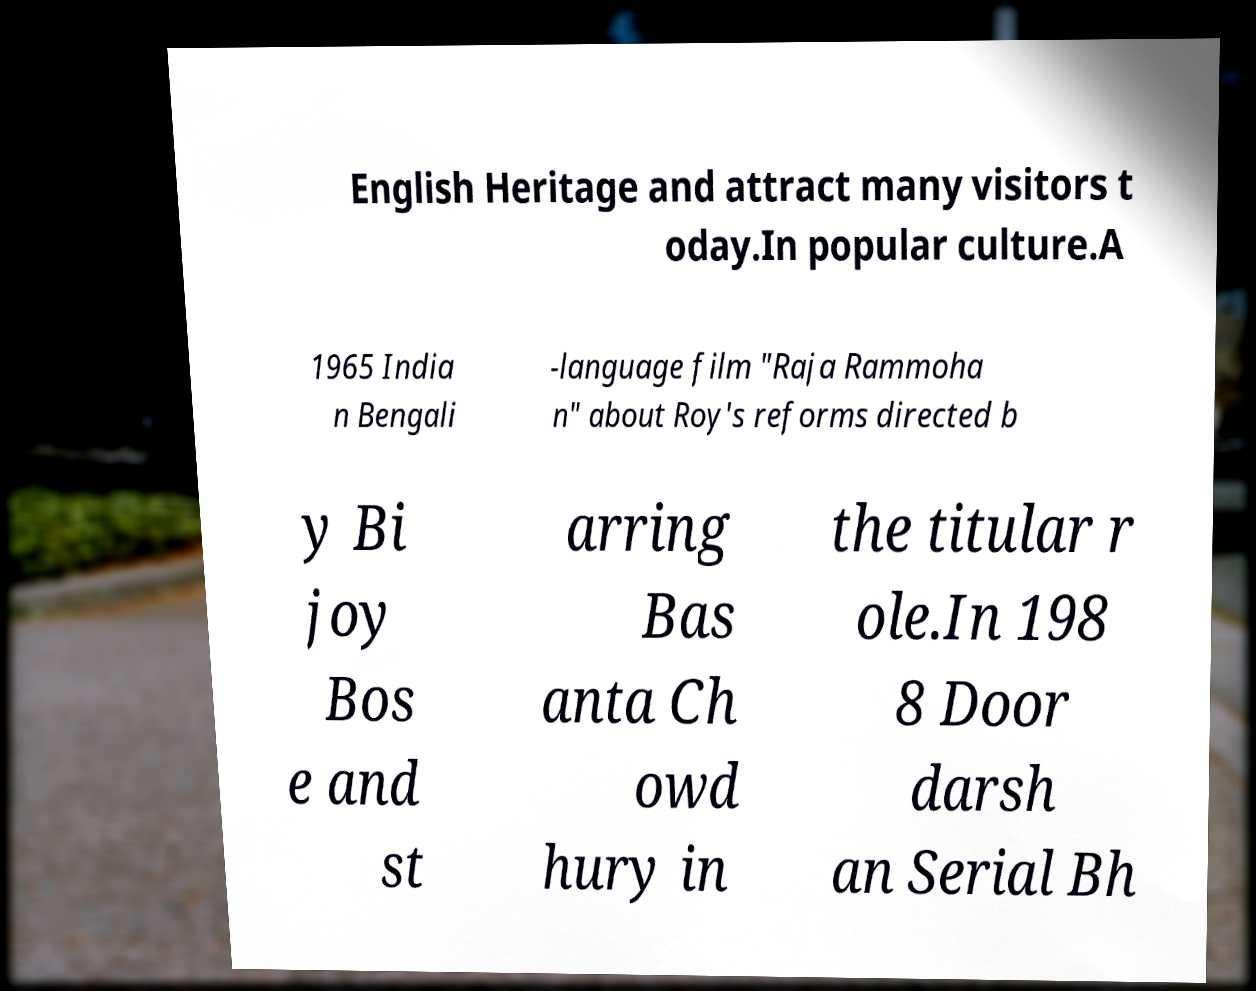I need the written content from this picture converted into text. Can you do that? English Heritage and attract many visitors t oday.In popular culture.A 1965 India n Bengali -language film "Raja Rammoha n" about Roy's reforms directed b y Bi joy Bos e and st arring Bas anta Ch owd hury in the titular r ole.In 198 8 Door darsh an Serial Bh 